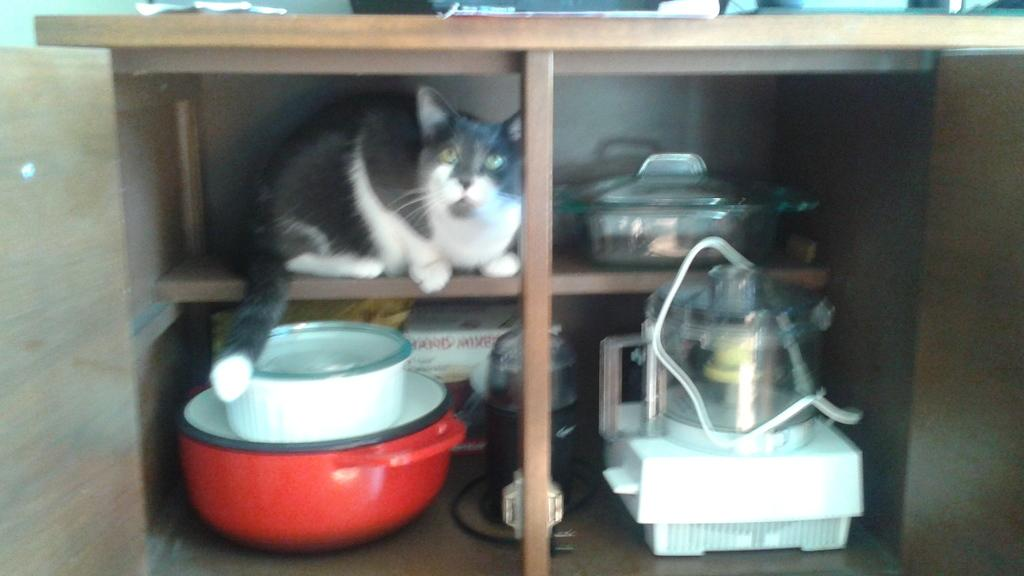What is the color of the rack in the image? The rack in the image is brown in color. What can be seen inside the rack? A cat is present inside the rack. Can you describe the appearance of the cat? The cat is white and black in color. What other items are present in the rack? There are utensils, a pan, and a mixer grinder visible in the rack. How many rats are visible in the image? There are no rats present in the image. What type of hammer is being used by the group in the image? There is no group or hammer present in the image. 